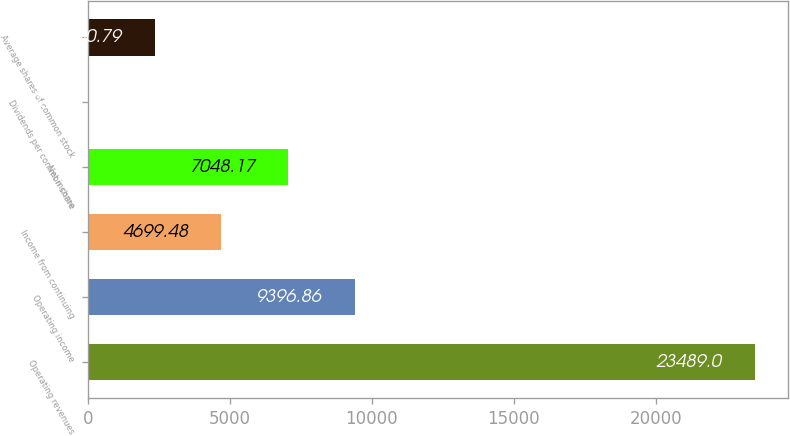<chart> <loc_0><loc_0><loc_500><loc_500><bar_chart><fcel>Operating revenues<fcel>Operating income<fcel>Income from continuing<fcel>Net income<fcel>Dividends per common share<fcel>Average shares of common stock<nl><fcel>23489<fcel>9396.86<fcel>4699.48<fcel>7048.17<fcel>2.1<fcel>2350.79<nl></chart> 